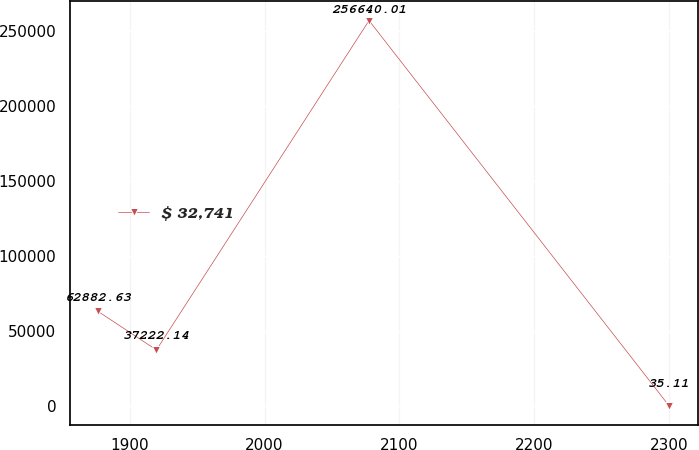Convert chart. <chart><loc_0><loc_0><loc_500><loc_500><line_chart><ecel><fcel>$ 32,741<nl><fcel>1876.63<fcel>62882.6<nl><fcel>1919.9<fcel>37222.1<nl><fcel>2077.47<fcel>256640<nl><fcel>2299.83<fcel>35.11<nl></chart> 